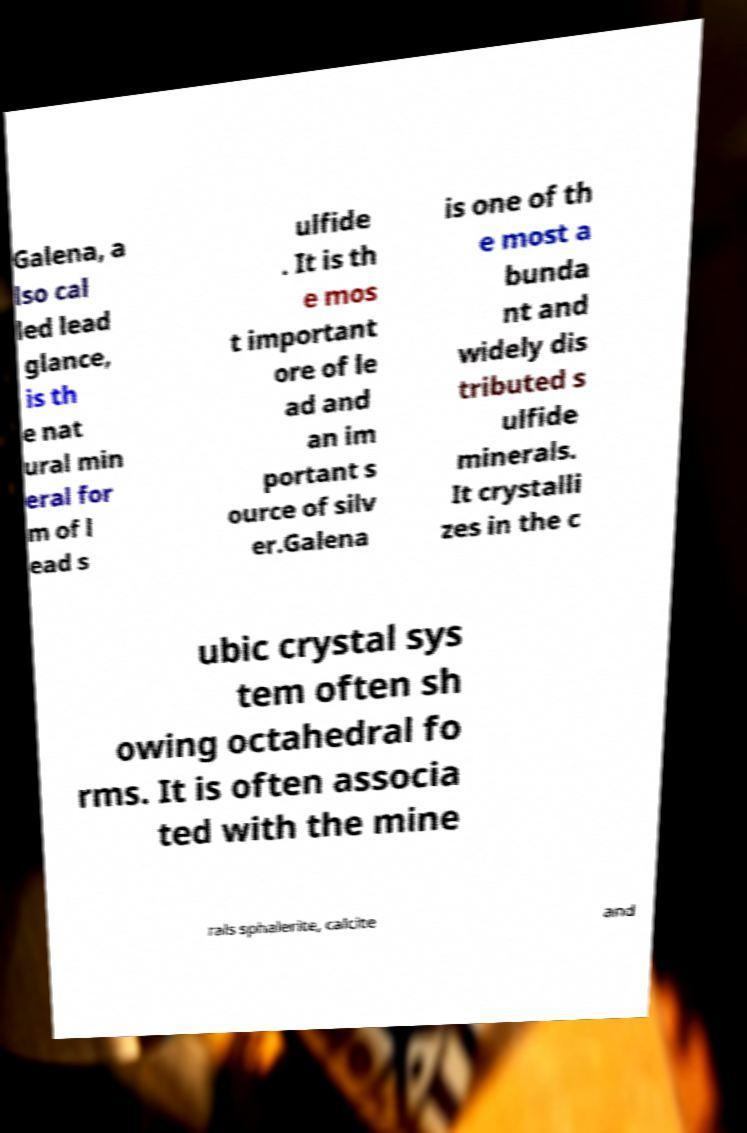Can you accurately transcribe the text from the provided image for me? Galena, a lso cal led lead glance, is th e nat ural min eral for m of l ead s ulfide . It is th e mos t important ore of le ad and an im portant s ource of silv er.Galena is one of th e most a bunda nt and widely dis tributed s ulfide minerals. It crystalli zes in the c ubic crystal sys tem often sh owing octahedral fo rms. It is often associa ted with the mine rals sphalerite, calcite and 